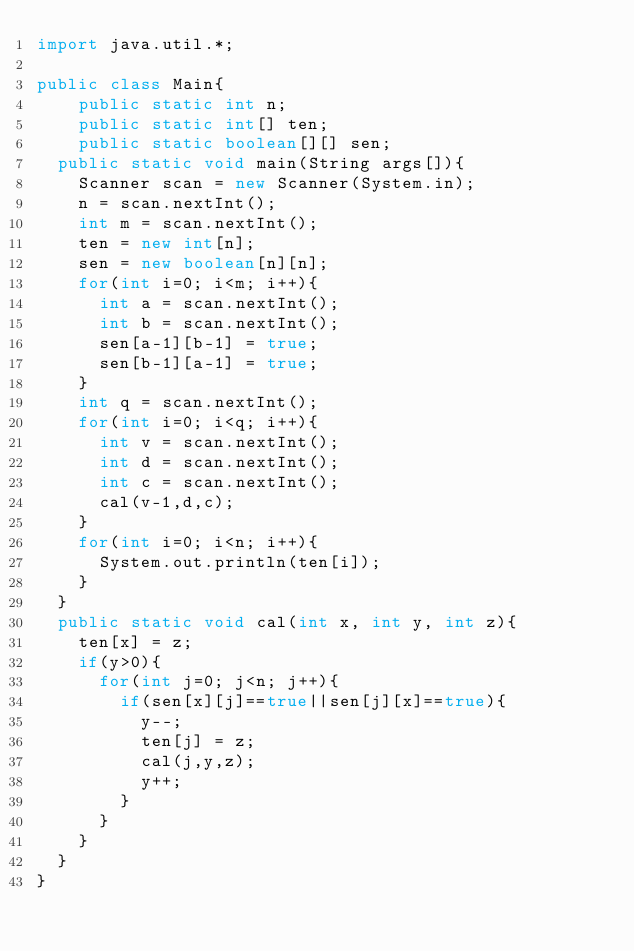<code> <loc_0><loc_0><loc_500><loc_500><_Java_>import java.util.*;

public class Main{
		public static int n;
		public static int[] ten;
		public static boolean[][] sen;
	public static void main(String args[]){
		Scanner scan = new Scanner(System.in);
		n = scan.nextInt();
		int m = scan.nextInt();
		ten = new int[n];
		sen = new boolean[n][n];
		for(int i=0; i<m; i++){
			int a = scan.nextInt();
			int b = scan.nextInt();
			sen[a-1][b-1] = true;
			sen[b-1][a-1] = true;
		}
		int q = scan.nextInt();
		for(int i=0; i<q; i++){
			int v = scan.nextInt();
			int d = scan.nextInt();
			int c = scan.nextInt();
			cal(v-1,d,c);
		}
		for(int i=0; i<n; i++){
			System.out.println(ten[i]);
		}
	}
	public static void cal(int x, int y, int z){
		ten[x] = z;
		if(y>0){
			for(int j=0; j<n; j++){
				if(sen[x][j]==true||sen[j][x]==true){
					y--;
					ten[j] = z;
					cal(j,y,z);
					y++;
				}
			}
		} 
	}
}</code> 